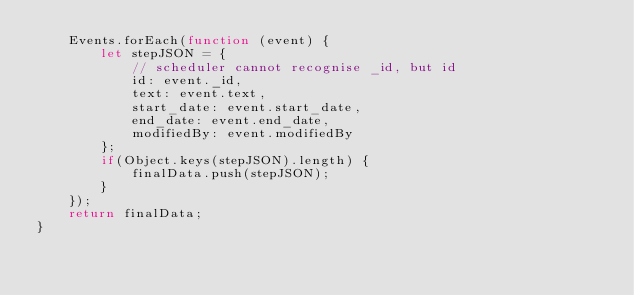<code> <loc_0><loc_0><loc_500><loc_500><_JavaScript_>    Events.forEach(function (event) {
        let stepJSON = {
            // scheduler cannot recognise _id, but id
            id: event._id,
            text: event.text,
            start_date: event.start_date,
            end_date: event.end_date,
            modifiedBy: event.modifiedBy
        };
        if(Object.keys(stepJSON).length) {
            finalData.push(stepJSON);
        }
    });
    return finalData;
}</code> 